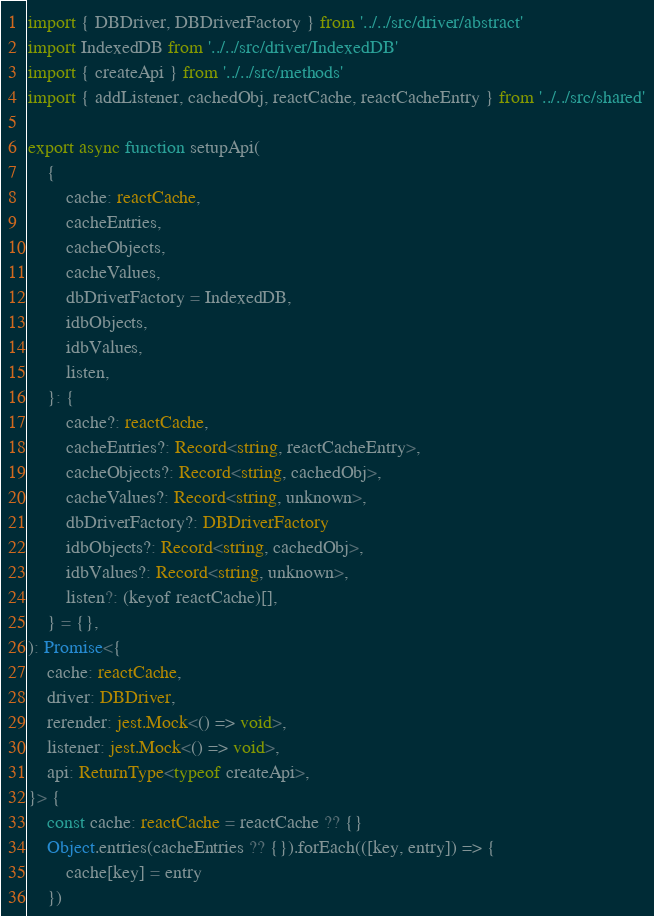Convert code to text. <code><loc_0><loc_0><loc_500><loc_500><_TypeScript_>import { DBDriver, DBDriverFactory } from '../../src/driver/abstract'
import IndexedDB from '../../src/driver/IndexedDB'
import { createApi } from '../../src/methods'
import { addListener, cachedObj, reactCache, reactCacheEntry } from '../../src/shared'

export async function setupApi(
    {
        cache: reactCache,
        cacheEntries,
        cacheObjects,
        cacheValues,
        dbDriverFactory = IndexedDB,
        idbObjects,
        idbValues,
        listen,
    }: {
        cache?: reactCache,
        cacheEntries?: Record<string, reactCacheEntry>,
        cacheObjects?: Record<string, cachedObj>,
        cacheValues?: Record<string, unknown>,
        dbDriverFactory?: DBDriverFactory
        idbObjects?: Record<string, cachedObj>,
        idbValues?: Record<string, unknown>,
        listen?: (keyof reactCache)[],
    } = {},
): Promise<{
    cache: reactCache,
    driver: DBDriver,
    rerender: jest.Mock<() => void>,
    listener: jest.Mock<() => void>,
    api: ReturnType<typeof createApi>,
}> {
    const cache: reactCache = reactCache ?? {}
    Object.entries(cacheEntries ?? {}).forEach(([key, entry]) => {
        cache[key] = entry
    })</code> 